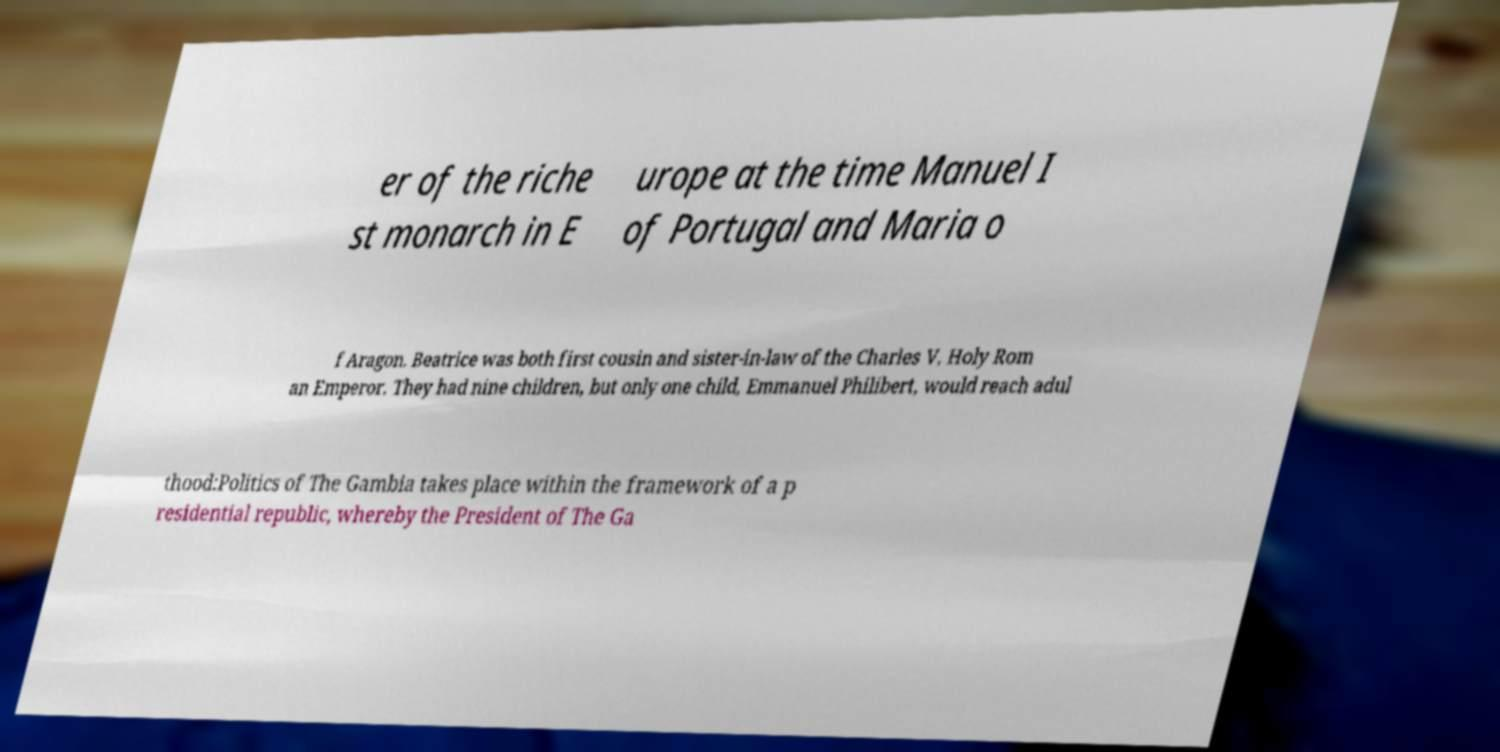I need the written content from this picture converted into text. Can you do that? er of the riche st monarch in E urope at the time Manuel I of Portugal and Maria o f Aragon. Beatrice was both first cousin and sister-in-law of the Charles V, Holy Rom an Emperor. They had nine children, but only one child, Emmanuel Philibert, would reach adul thood:Politics of The Gambia takes place within the framework of a p residential republic, whereby the President of The Ga 